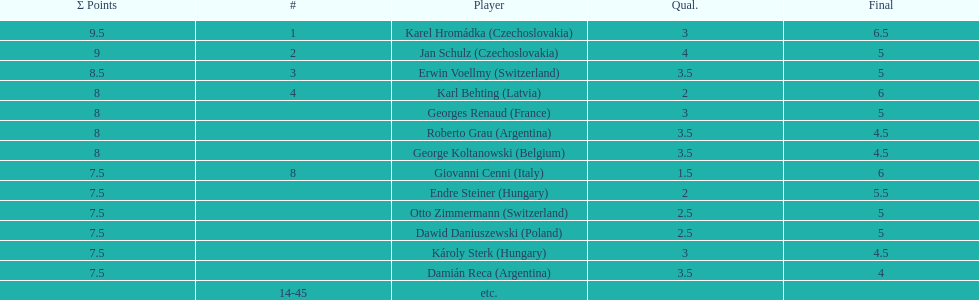In the consolation cup, how many nations were represented by more than one player? 4. Can you parse all the data within this table? {'header': ['Σ Points', '#', 'Player', 'Qual.', 'Final'], 'rows': [['9.5', '1', 'Karel Hromádka\xa0(Czechoslovakia)', '3', '6.5'], ['9', '2', 'Jan Schulz\xa0(Czechoslovakia)', '4', '5'], ['8.5', '3', 'Erwin Voellmy\xa0(Switzerland)', '3.5', '5'], ['8', '4', 'Karl Behting\xa0(Latvia)', '2', '6'], ['8', '', 'Georges Renaud\xa0(France)', '3', '5'], ['8', '', 'Roberto Grau\xa0(Argentina)', '3.5', '4.5'], ['8', '', 'George Koltanowski\xa0(Belgium)', '3.5', '4.5'], ['7.5', '8', 'Giovanni Cenni\xa0(Italy)', '1.5', '6'], ['7.5', '', 'Endre Steiner\xa0(Hungary)', '2', '5.5'], ['7.5', '', 'Otto Zimmermann\xa0(Switzerland)', '2.5', '5'], ['7.5', '', 'Dawid Daniuszewski\xa0(Poland)', '2.5', '5'], ['7.5', '', 'Károly Sterk\xa0(Hungary)', '3', '4.5'], ['7.5', '', 'Damián Reca\xa0(Argentina)', '3.5', '4'], ['', '14-45', 'etc.', '', '']]} 